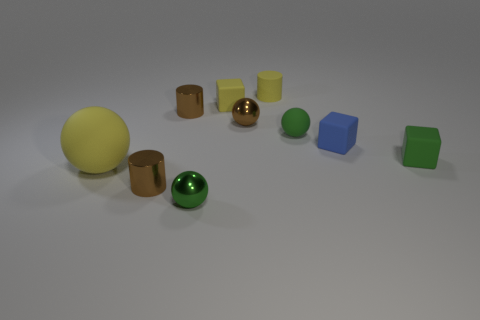Subtract all blue rubber blocks. How many blocks are left? 2 Subtract all yellow spheres. How many spheres are left? 3 Subtract all cubes. How many objects are left? 7 Add 9 small green cubes. How many small green cubes are left? 10 Add 5 big blocks. How many big blocks exist? 5 Subtract 0 purple cubes. How many objects are left? 10 Subtract 2 cylinders. How many cylinders are left? 1 Subtract all brown cylinders. Subtract all gray blocks. How many cylinders are left? 1 Subtract all blue spheres. How many brown blocks are left? 0 Subtract all metal objects. Subtract all cylinders. How many objects are left? 3 